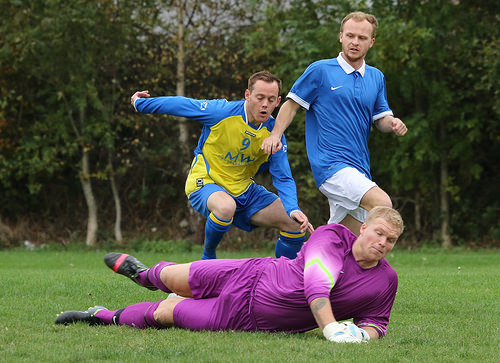<image>
Can you confirm if the man is behind the man? No. The man is not behind the man. From this viewpoint, the man appears to be positioned elsewhere in the scene. Where is the man in relation to the man? Is it in front of the man? No. The man is not in front of the man. The spatial positioning shows a different relationship between these objects. 